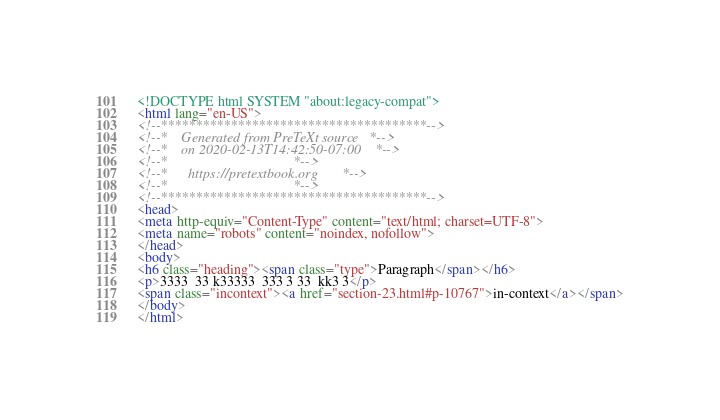Convert code to text. <code><loc_0><loc_0><loc_500><loc_500><_HTML_><!DOCTYPE html SYSTEM "about:legacy-compat">
<html lang="en-US">
<!--**************************************-->
<!--*    Generated from PreTeXt source   *-->
<!--*    on 2020-02-13T14:42:50-07:00    *-->
<!--*                                    *-->
<!--*      https://pretextbook.org       *-->
<!--*                                    *-->
<!--**************************************-->
<head>
<meta http-equiv="Content-Type" content="text/html; charset=UTF-8">
<meta name="robots" content="noindex, nofollow">
</head>
<body>
<h6 class="heading"><span class="type">Paragraph</span></h6>
<p>3333  33 k33333  333 3 33  kk3 3</p>
<span class="incontext"><a href="section-23.html#p-10767">in-context</a></span>
</body>
</html>
</code> 